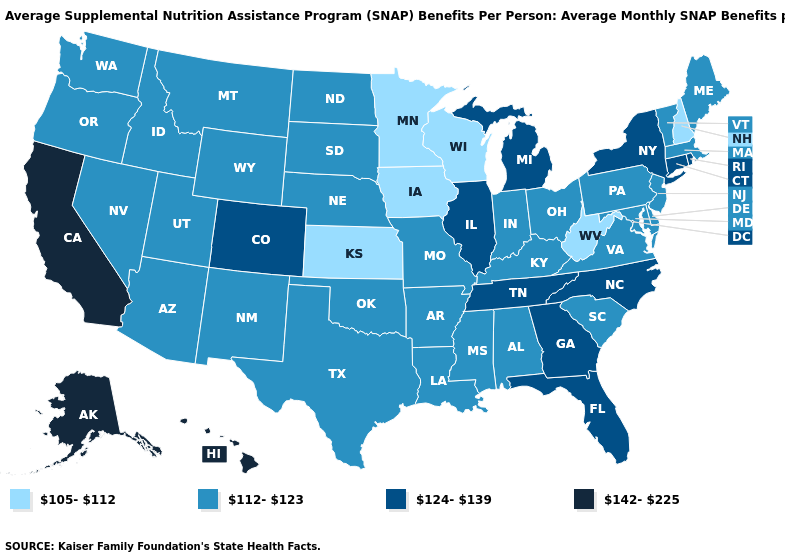Does the map have missing data?
Keep it brief. No. Is the legend a continuous bar?
Concise answer only. No. What is the value of Connecticut?
Give a very brief answer. 124-139. Which states have the lowest value in the West?
Concise answer only. Arizona, Idaho, Montana, Nevada, New Mexico, Oregon, Utah, Washington, Wyoming. Does the first symbol in the legend represent the smallest category?
Concise answer only. Yes. What is the value of Virginia?
Concise answer only. 112-123. What is the value of Florida?
Give a very brief answer. 124-139. What is the value of Arkansas?
Write a very short answer. 112-123. Which states have the lowest value in the South?
Keep it brief. West Virginia. Name the states that have a value in the range 142-225?
Answer briefly. Alaska, California, Hawaii. Does Ohio have a lower value than Nebraska?
Be succinct. No. What is the value of Ohio?
Quick response, please. 112-123. Does Rhode Island have the lowest value in the Northeast?
Write a very short answer. No. 